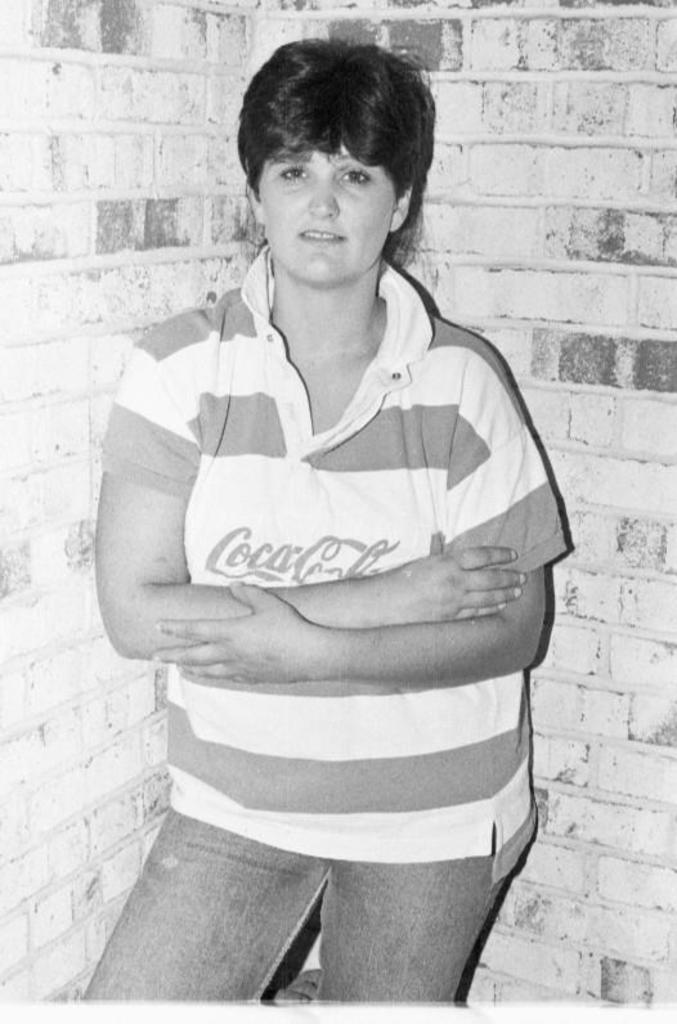What is the main subject of the image? There is a lady standing in the image. Can you describe the background of the image? There is a wall in the background of the image. What type of soup is being served in the image? There is no soup present in the image; it only features a lady standing and a wall in the background. 